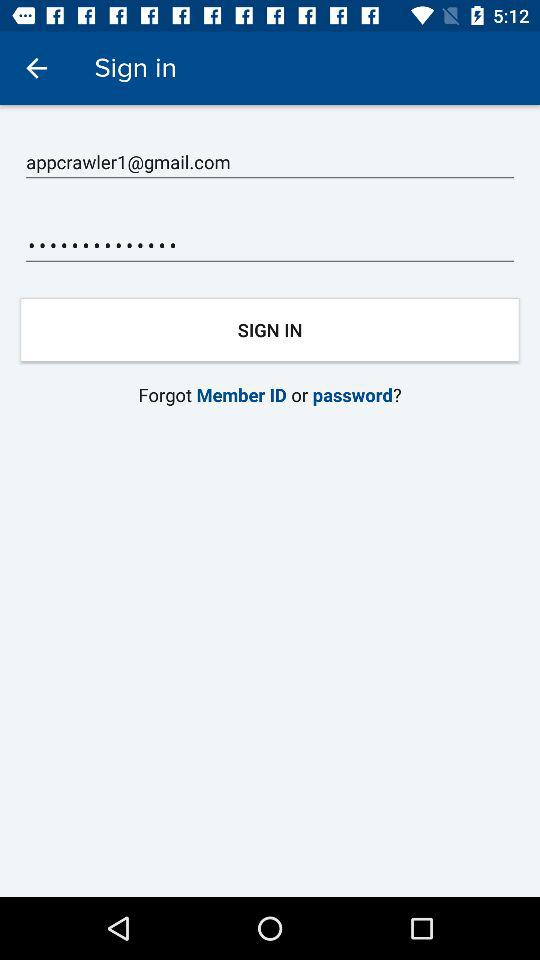How many text input fields are there on this screen?
Answer the question using a single word or phrase. 2 